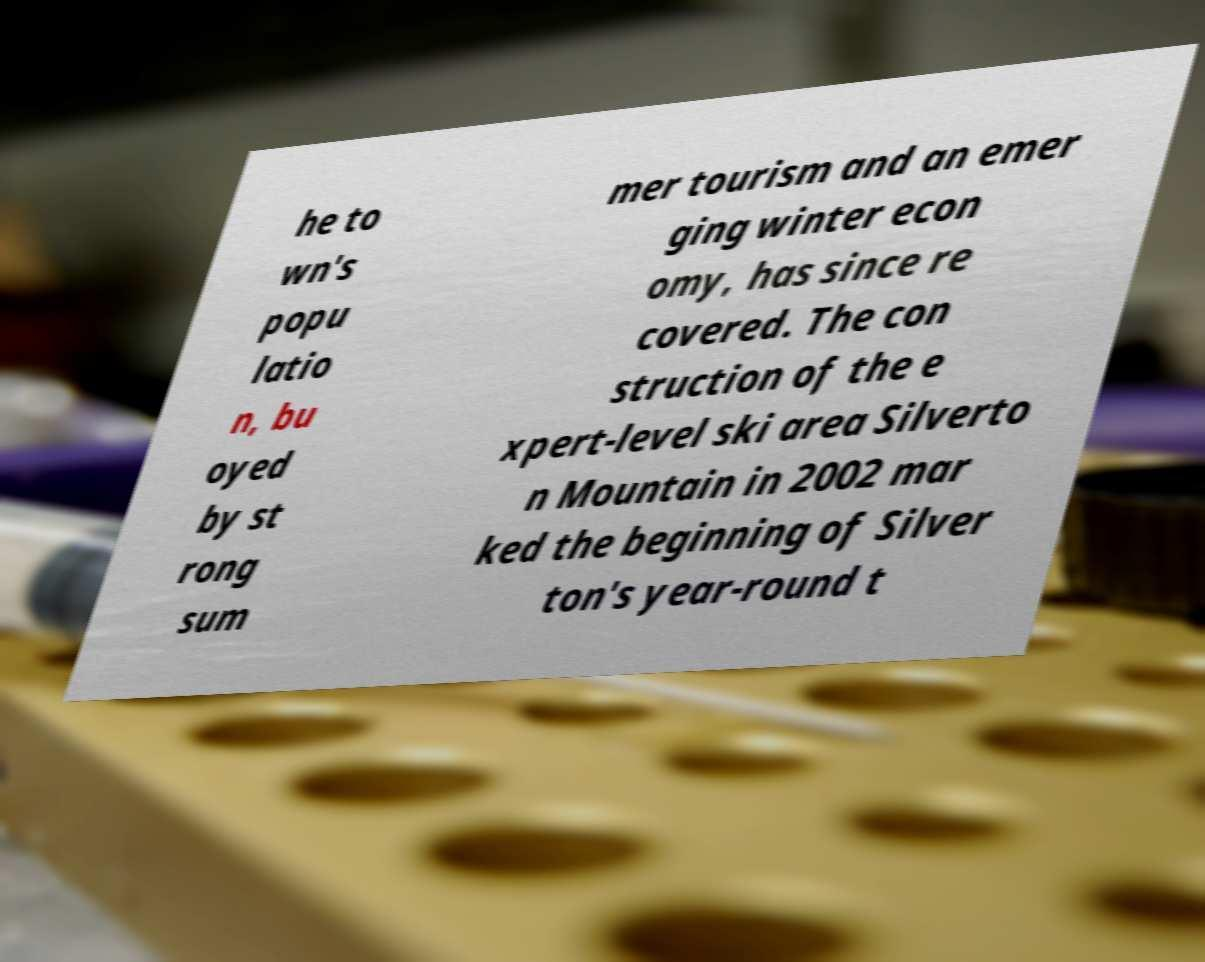Could you extract and type out the text from this image? he to wn's popu latio n, bu oyed by st rong sum mer tourism and an emer ging winter econ omy, has since re covered. The con struction of the e xpert-level ski area Silverto n Mountain in 2002 mar ked the beginning of Silver ton's year-round t 